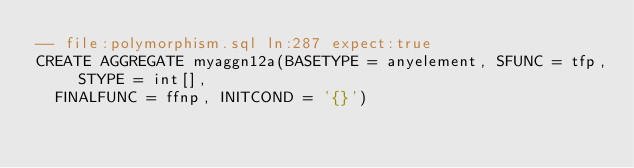Convert code to text. <code><loc_0><loc_0><loc_500><loc_500><_SQL_>-- file:polymorphism.sql ln:287 expect:true
CREATE AGGREGATE myaggn12a(BASETYPE = anyelement, SFUNC = tfp, STYPE = int[],
  FINALFUNC = ffnp, INITCOND = '{}')
</code> 